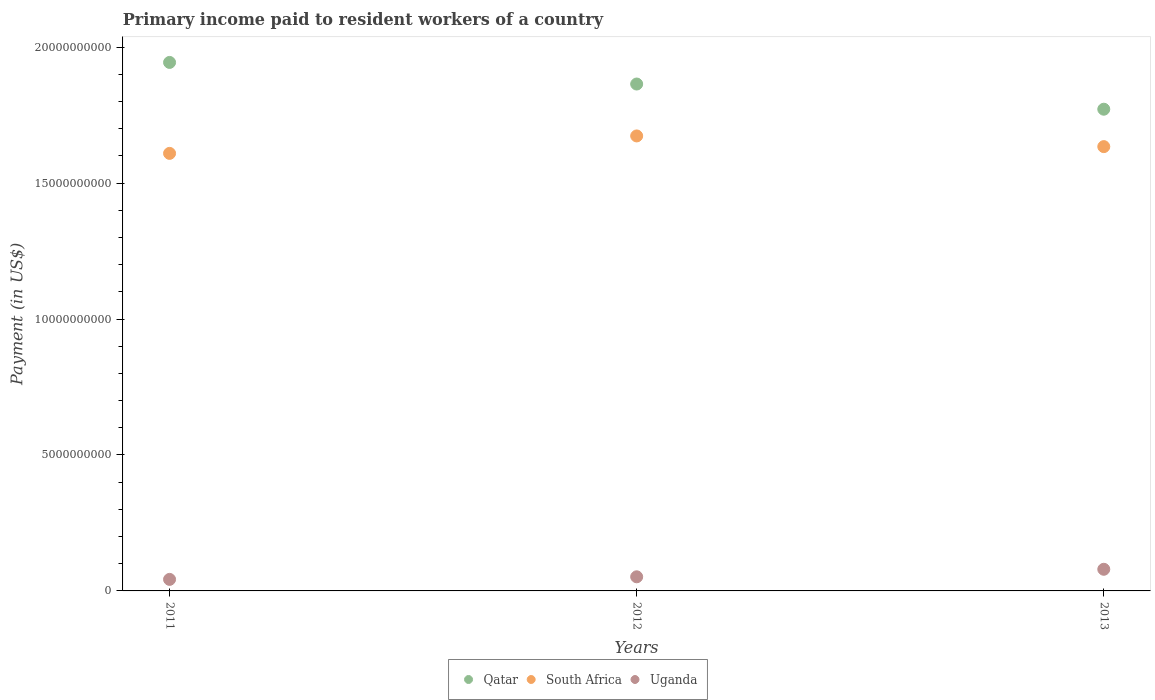How many different coloured dotlines are there?
Provide a short and direct response. 3. Is the number of dotlines equal to the number of legend labels?
Keep it short and to the point. Yes. What is the amount paid to workers in Uganda in 2012?
Give a very brief answer. 5.19e+08. Across all years, what is the maximum amount paid to workers in Qatar?
Offer a terse response. 1.94e+1. Across all years, what is the minimum amount paid to workers in South Africa?
Keep it short and to the point. 1.61e+1. In which year was the amount paid to workers in Qatar maximum?
Your answer should be very brief. 2011. In which year was the amount paid to workers in Uganda minimum?
Your answer should be very brief. 2011. What is the total amount paid to workers in South Africa in the graph?
Keep it short and to the point. 4.92e+1. What is the difference between the amount paid to workers in Qatar in 2011 and that in 2012?
Provide a succinct answer. 7.94e+08. What is the difference between the amount paid to workers in South Africa in 2011 and the amount paid to workers in Qatar in 2013?
Your answer should be very brief. -1.62e+09. What is the average amount paid to workers in Uganda per year?
Make the answer very short. 5.80e+08. In the year 2012, what is the difference between the amount paid to workers in South Africa and amount paid to workers in Qatar?
Your answer should be compact. -1.91e+09. What is the ratio of the amount paid to workers in South Africa in 2012 to that in 2013?
Ensure brevity in your answer.  1.02. Is the difference between the amount paid to workers in South Africa in 2011 and 2013 greater than the difference between the amount paid to workers in Qatar in 2011 and 2013?
Give a very brief answer. No. What is the difference between the highest and the second highest amount paid to workers in Uganda?
Your answer should be very brief. 2.77e+08. What is the difference between the highest and the lowest amount paid to workers in Qatar?
Offer a terse response. 1.72e+09. Is the sum of the amount paid to workers in Qatar in 2012 and 2013 greater than the maximum amount paid to workers in South Africa across all years?
Offer a terse response. Yes. Does the amount paid to workers in South Africa monotonically increase over the years?
Make the answer very short. No. Does the graph contain any zero values?
Your response must be concise. No. Does the graph contain grids?
Your answer should be compact. No. What is the title of the graph?
Your answer should be compact. Primary income paid to resident workers of a country. What is the label or title of the Y-axis?
Offer a terse response. Payment (in US$). What is the Payment (in US$) of Qatar in 2011?
Provide a short and direct response. 1.94e+1. What is the Payment (in US$) in South Africa in 2011?
Your answer should be compact. 1.61e+1. What is the Payment (in US$) of Uganda in 2011?
Provide a short and direct response. 4.24e+08. What is the Payment (in US$) in Qatar in 2012?
Your answer should be very brief. 1.86e+1. What is the Payment (in US$) of South Africa in 2012?
Provide a succinct answer. 1.67e+1. What is the Payment (in US$) in Uganda in 2012?
Make the answer very short. 5.19e+08. What is the Payment (in US$) of Qatar in 2013?
Your answer should be very brief. 1.77e+1. What is the Payment (in US$) in South Africa in 2013?
Your response must be concise. 1.63e+1. What is the Payment (in US$) of Uganda in 2013?
Offer a very short reply. 7.96e+08. Across all years, what is the maximum Payment (in US$) of Qatar?
Offer a very short reply. 1.94e+1. Across all years, what is the maximum Payment (in US$) of South Africa?
Offer a very short reply. 1.67e+1. Across all years, what is the maximum Payment (in US$) of Uganda?
Provide a short and direct response. 7.96e+08. Across all years, what is the minimum Payment (in US$) of Qatar?
Offer a very short reply. 1.77e+1. Across all years, what is the minimum Payment (in US$) of South Africa?
Make the answer very short. 1.61e+1. Across all years, what is the minimum Payment (in US$) of Uganda?
Offer a very short reply. 4.24e+08. What is the total Payment (in US$) in Qatar in the graph?
Provide a succinct answer. 5.58e+1. What is the total Payment (in US$) in South Africa in the graph?
Provide a succinct answer. 4.92e+1. What is the total Payment (in US$) in Uganda in the graph?
Keep it short and to the point. 1.74e+09. What is the difference between the Payment (in US$) of Qatar in 2011 and that in 2012?
Provide a succinct answer. 7.94e+08. What is the difference between the Payment (in US$) of South Africa in 2011 and that in 2012?
Keep it short and to the point. -6.41e+08. What is the difference between the Payment (in US$) in Uganda in 2011 and that in 2012?
Offer a very short reply. -9.51e+07. What is the difference between the Payment (in US$) of Qatar in 2011 and that in 2013?
Offer a very short reply. 1.72e+09. What is the difference between the Payment (in US$) in South Africa in 2011 and that in 2013?
Offer a very short reply. -2.48e+08. What is the difference between the Payment (in US$) of Uganda in 2011 and that in 2013?
Ensure brevity in your answer.  -3.72e+08. What is the difference between the Payment (in US$) of Qatar in 2012 and that in 2013?
Offer a very short reply. 9.26e+08. What is the difference between the Payment (in US$) in South Africa in 2012 and that in 2013?
Offer a terse response. 3.93e+08. What is the difference between the Payment (in US$) in Uganda in 2012 and that in 2013?
Your answer should be very brief. -2.77e+08. What is the difference between the Payment (in US$) of Qatar in 2011 and the Payment (in US$) of South Africa in 2012?
Your answer should be very brief. 2.70e+09. What is the difference between the Payment (in US$) of Qatar in 2011 and the Payment (in US$) of Uganda in 2012?
Make the answer very short. 1.89e+1. What is the difference between the Payment (in US$) in South Africa in 2011 and the Payment (in US$) in Uganda in 2012?
Provide a short and direct response. 1.56e+1. What is the difference between the Payment (in US$) in Qatar in 2011 and the Payment (in US$) in South Africa in 2013?
Your answer should be compact. 3.10e+09. What is the difference between the Payment (in US$) of Qatar in 2011 and the Payment (in US$) of Uganda in 2013?
Offer a very short reply. 1.86e+1. What is the difference between the Payment (in US$) in South Africa in 2011 and the Payment (in US$) in Uganda in 2013?
Your response must be concise. 1.53e+1. What is the difference between the Payment (in US$) of Qatar in 2012 and the Payment (in US$) of South Africa in 2013?
Offer a very short reply. 2.30e+09. What is the difference between the Payment (in US$) in Qatar in 2012 and the Payment (in US$) in Uganda in 2013?
Provide a short and direct response. 1.78e+1. What is the difference between the Payment (in US$) in South Africa in 2012 and the Payment (in US$) in Uganda in 2013?
Give a very brief answer. 1.59e+1. What is the average Payment (in US$) in Qatar per year?
Ensure brevity in your answer.  1.86e+1. What is the average Payment (in US$) in South Africa per year?
Provide a succinct answer. 1.64e+1. What is the average Payment (in US$) of Uganda per year?
Provide a short and direct response. 5.80e+08. In the year 2011, what is the difference between the Payment (in US$) of Qatar and Payment (in US$) of South Africa?
Make the answer very short. 3.35e+09. In the year 2011, what is the difference between the Payment (in US$) in Qatar and Payment (in US$) in Uganda?
Make the answer very short. 1.90e+1. In the year 2011, what is the difference between the Payment (in US$) of South Africa and Payment (in US$) of Uganda?
Ensure brevity in your answer.  1.57e+1. In the year 2012, what is the difference between the Payment (in US$) in Qatar and Payment (in US$) in South Africa?
Make the answer very short. 1.91e+09. In the year 2012, what is the difference between the Payment (in US$) of Qatar and Payment (in US$) of Uganda?
Offer a very short reply. 1.81e+1. In the year 2012, what is the difference between the Payment (in US$) of South Africa and Payment (in US$) of Uganda?
Make the answer very short. 1.62e+1. In the year 2013, what is the difference between the Payment (in US$) in Qatar and Payment (in US$) in South Africa?
Provide a succinct answer. 1.38e+09. In the year 2013, what is the difference between the Payment (in US$) in Qatar and Payment (in US$) in Uganda?
Your response must be concise. 1.69e+1. In the year 2013, what is the difference between the Payment (in US$) of South Africa and Payment (in US$) of Uganda?
Your answer should be compact. 1.55e+1. What is the ratio of the Payment (in US$) in Qatar in 2011 to that in 2012?
Provide a succinct answer. 1.04. What is the ratio of the Payment (in US$) in South Africa in 2011 to that in 2012?
Keep it short and to the point. 0.96. What is the ratio of the Payment (in US$) of Uganda in 2011 to that in 2012?
Your answer should be very brief. 0.82. What is the ratio of the Payment (in US$) of Qatar in 2011 to that in 2013?
Offer a very short reply. 1.1. What is the ratio of the Payment (in US$) in South Africa in 2011 to that in 2013?
Your answer should be compact. 0.98. What is the ratio of the Payment (in US$) of Uganda in 2011 to that in 2013?
Keep it short and to the point. 0.53. What is the ratio of the Payment (in US$) in Qatar in 2012 to that in 2013?
Your answer should be very brief. 1.05. What is the ratio of the Payment (in US$) of South Africa in 2012 to that in 2013?
Provide a succinct answer. 1.02. What is the ratio of the Payment (in US$) in Uganda in 2012 to that in 2013?
Your answer should be very brief. 0.65. What is the difference between the highest and the second highest Payment (in US$) of Qatar?
Give a very brief answer. 7.94e+08. What is the difference between the highest and the second highest Payment (in US$) in South Africa?
Make the answer very short. 3.93e+08. What is the difference between the highest and the second highest Payment (in US$) of Uganda?
Make the answer very short. 2.77e+08. What is the difference between the highest and the lowest Payment (in US$) of Qatar?
Keep it short and to the point. 1.72e+09. What is the difference between the highest and the lowest Payment (in US$) of South Africa?
Make the answer very short. 6.41e+08. What is the difference between the highest and the lowest Payment (in US$) in Uganda?
Provide a succinct answer. 3.72e+08. 